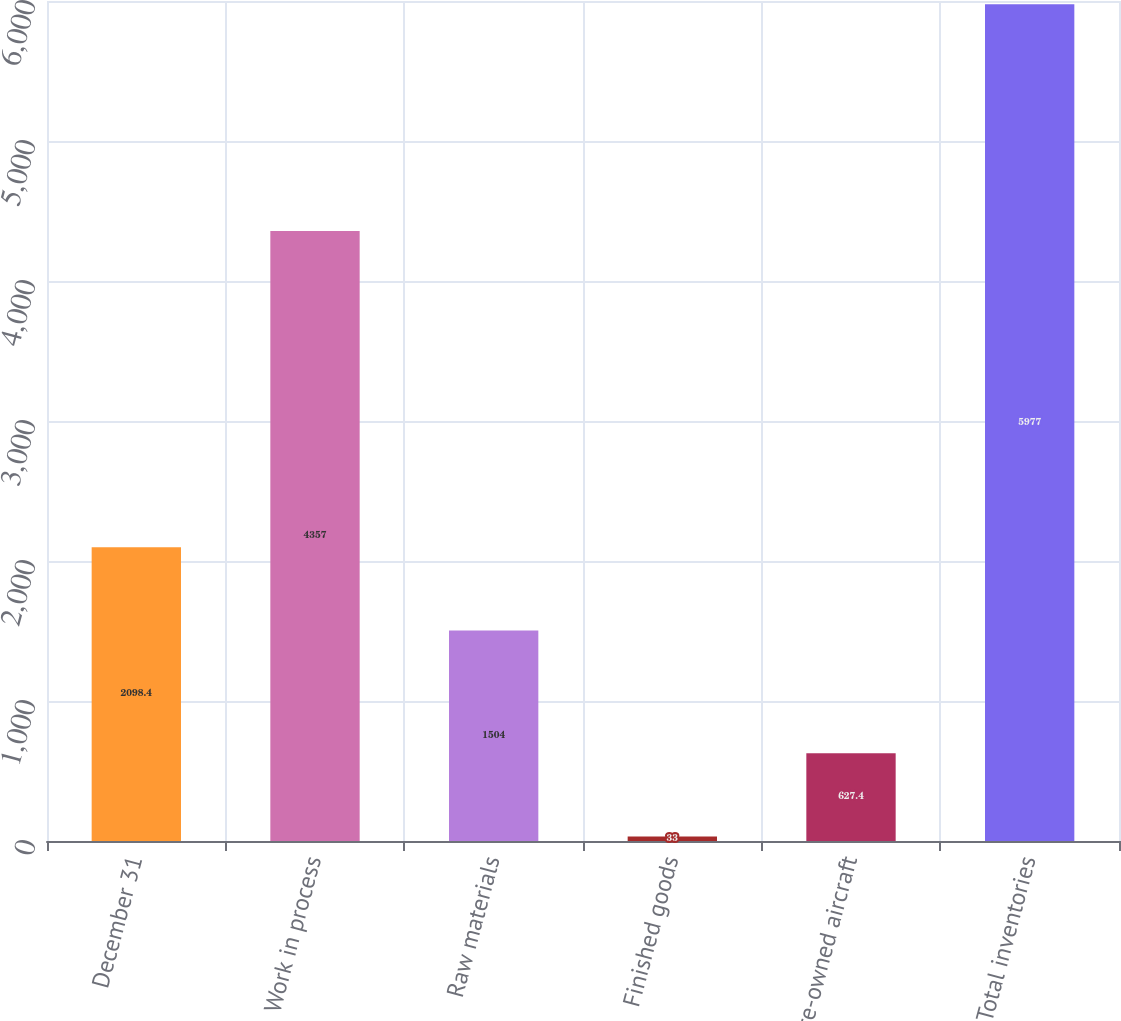Convert chart to OTSL. <chart><loc_0><loc_0><loc_500><loc_500><bar_chart><fcel>December 31<fcel>Work in process<fcel>Raw materials<fcel>Finished goods<fcel>Pre-owned aircraft<fcel>Total inventories<nl><fcel>2098.4<fcel>4357<fcel>1504<fcel>33<fcel>627.4<fcel>5977<nl></chart> 